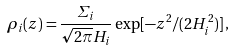<formula> <loc_0><loc_0><loc_500><loc_500>\rho _ { i } ( z ) = \frac { \varSigma _ { i } } { \sqrt { 2 \pi } H _ { i } } \exp [ - z ^ { 2 } / ( 2 H _ { i } ^ { 2 } ) ] \, ,</formula> 